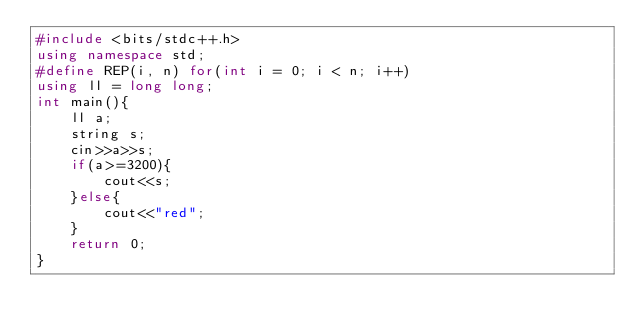<code> <loc_0><loc_0><loc_500><loc_500><_C++_>#include <bits/stdc++.h>
using namespace std;
#define REP(i, n) for(int i = 0; i < n; i++)
using ll = long long;
int main(){ 
    ll a;
    string s;
    cin>>a>>s;
    if(a>=3200){
        cout<<s;
    }else{
        cout<<"red";
    }
    return 0;
}
</code> 